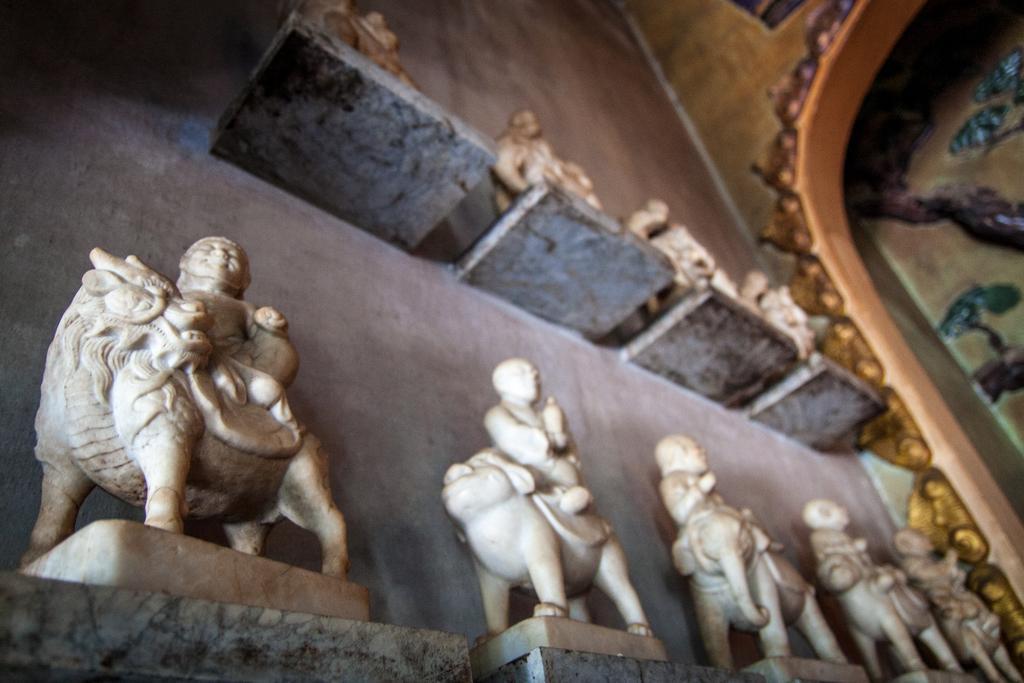Can you describe this image briefly? In this image there are idols kept on the shelves which are attached to the wall having sculptures. 